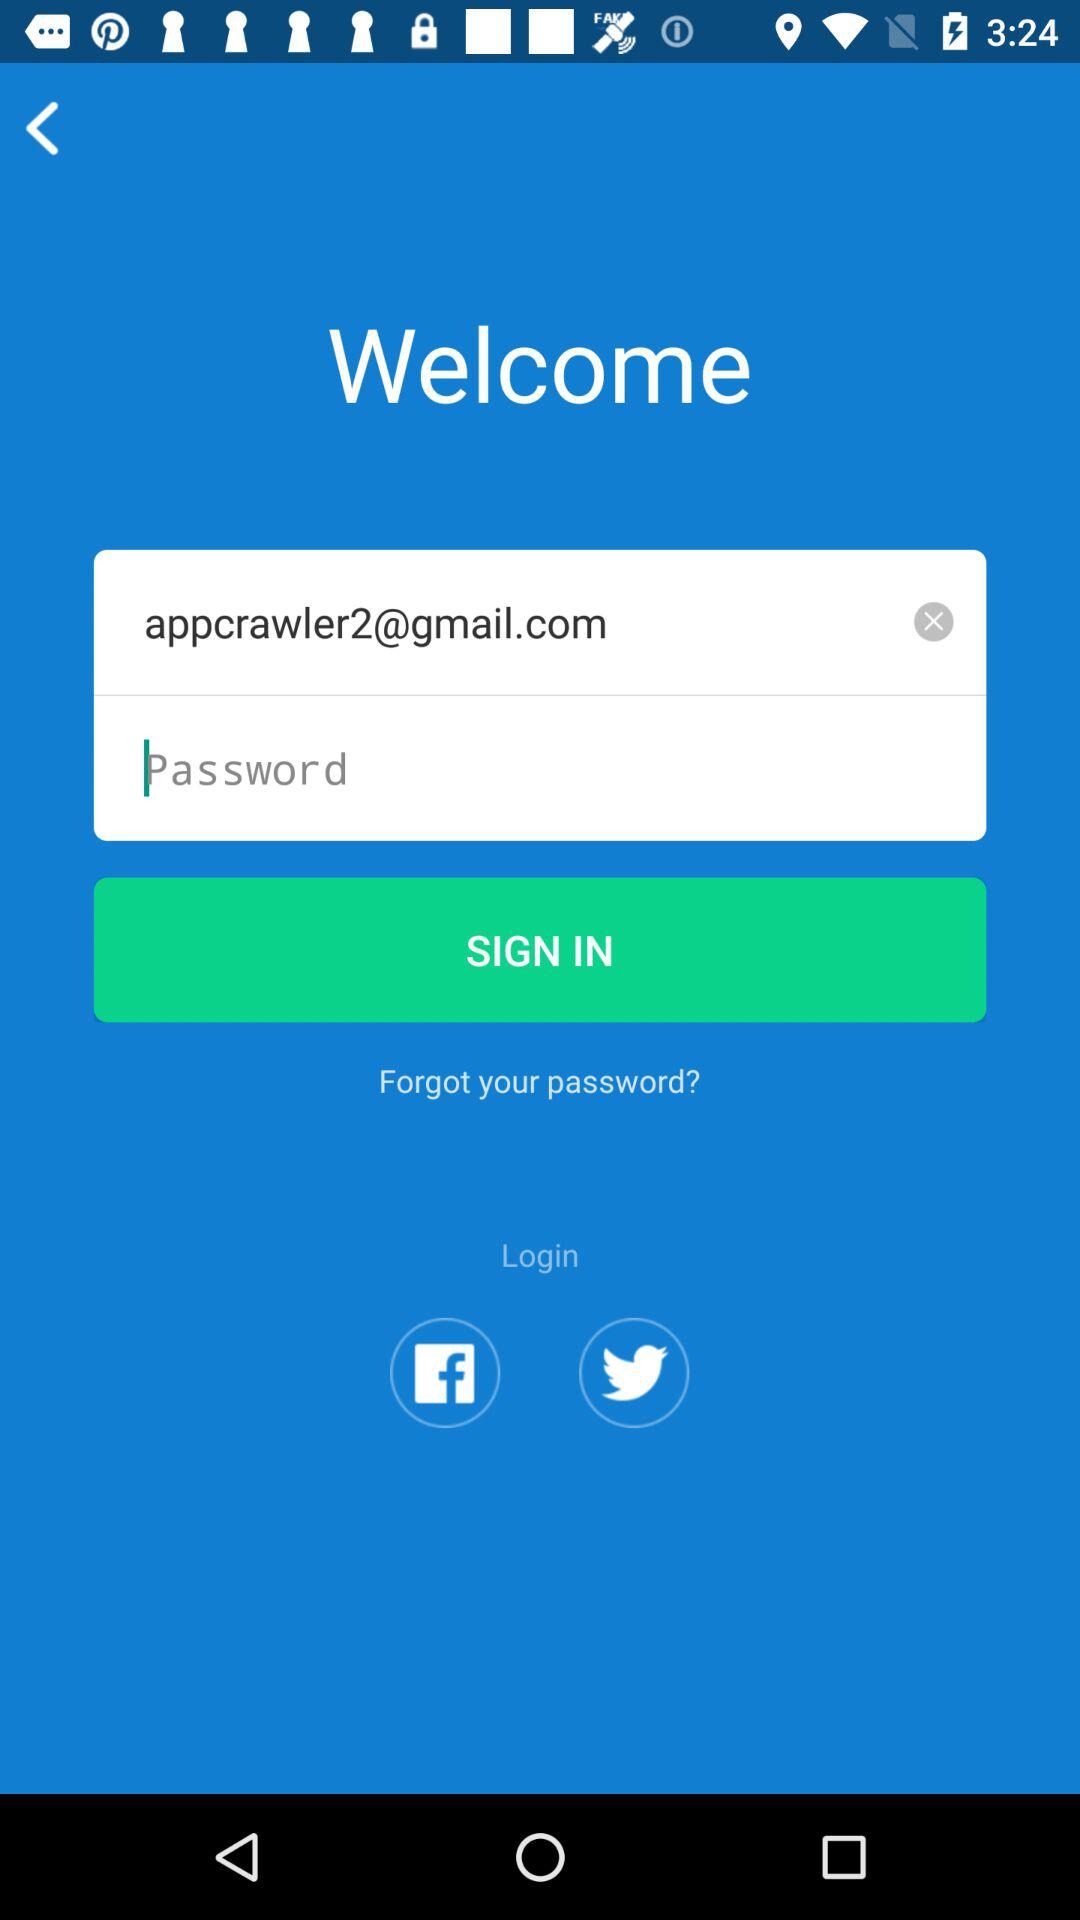What is the given email address? The given email address is appcrawler2@gmail.com. 